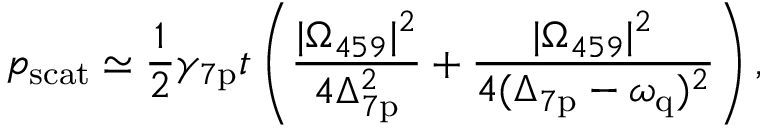<formula> <loc_0><loc_0><loc_500><loc_500>p _ { s c a t } \simeq \frac { 1 } { 2 } \gamma _ { 7 p } t \left ( \frac { | \Omega _ { 4 5 9 } | ^ { 2 } } { 4 \Delta _ { 7 p } ^ { 2 } } + \frac { | \Omega _ { 4 5 9 } | ^ { 2 } } { 4 ( \Delta _ { 7 p } - \omega _ { q } ) ^ { 2 } } \right ) ,</formula> 